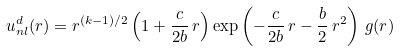<formula> <loc_0><loc_0><loc_500><loc_500>u _ { n l } ^ { d } ( r ) = r ^ { ( k - 1 ) / 2 } \left ( 1 + \frac { c } { 2 b } \, r \right ) \exp \left ( - \frac { c } { 2 b } \, r - \frac { b } { 2 } \, r ^ { 2 } \right ) \, g ( r )</formula> 